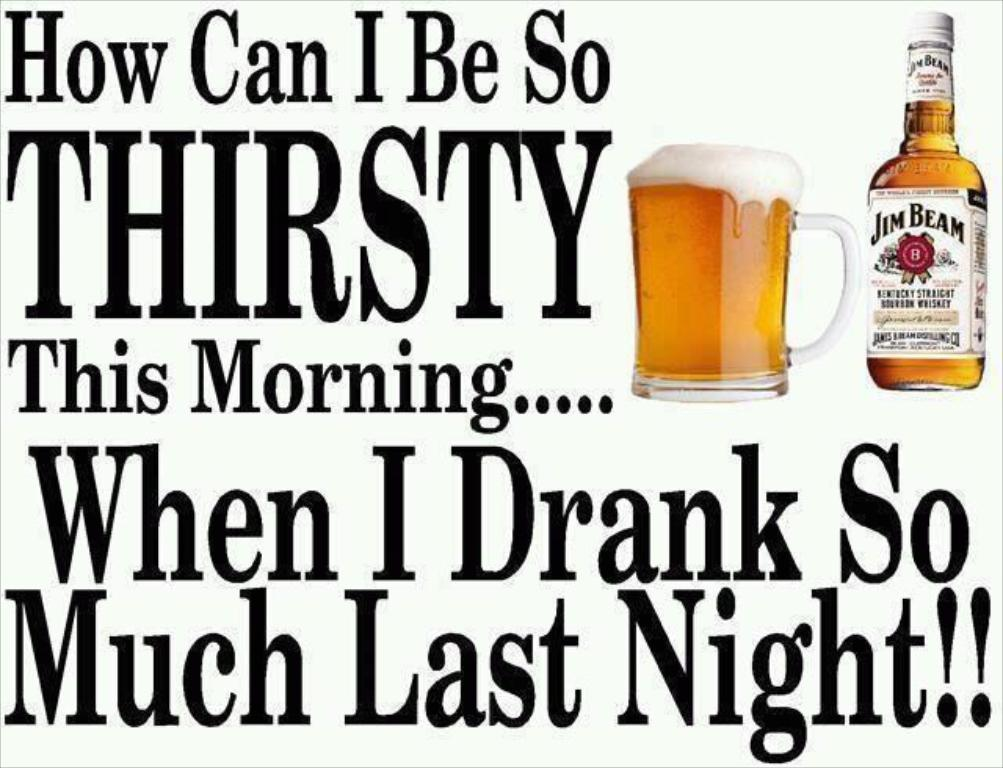<image>
Share a concise interpretation of the image provided. A bottle of Jim Beam is next to a mug. 